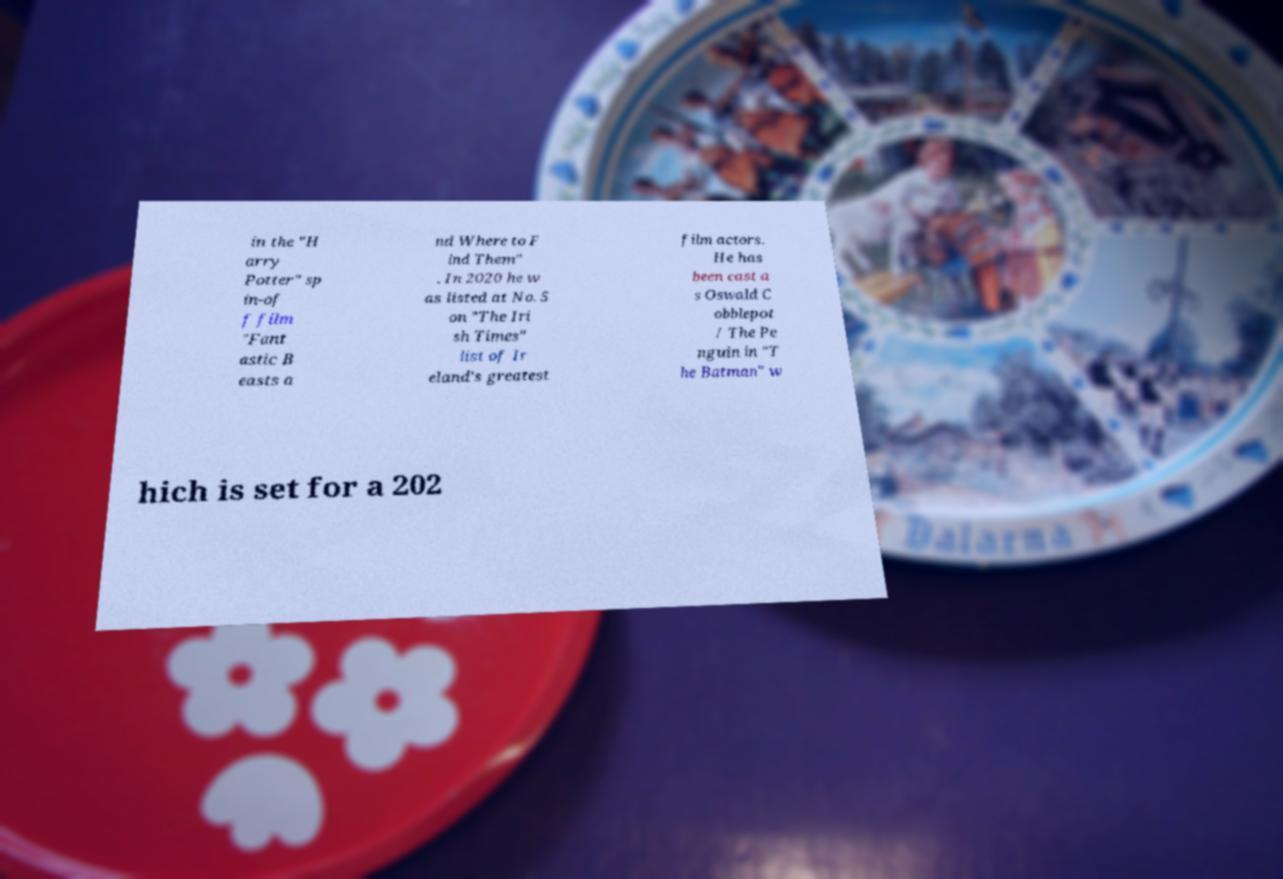I need the written content from this picture converted into text. Can you do that? in the "H arry Potter" sp in-of f film "Fant astic B easts a nd Where to F ind Them" . In 2020 he w as listed at No. 5 on "The Iri sh Times" list of Ir eland's greatest film actors. He has been cast a s Oswald C obblepot / The Pe nguin in "T he Batman" w hich is set for a 202 